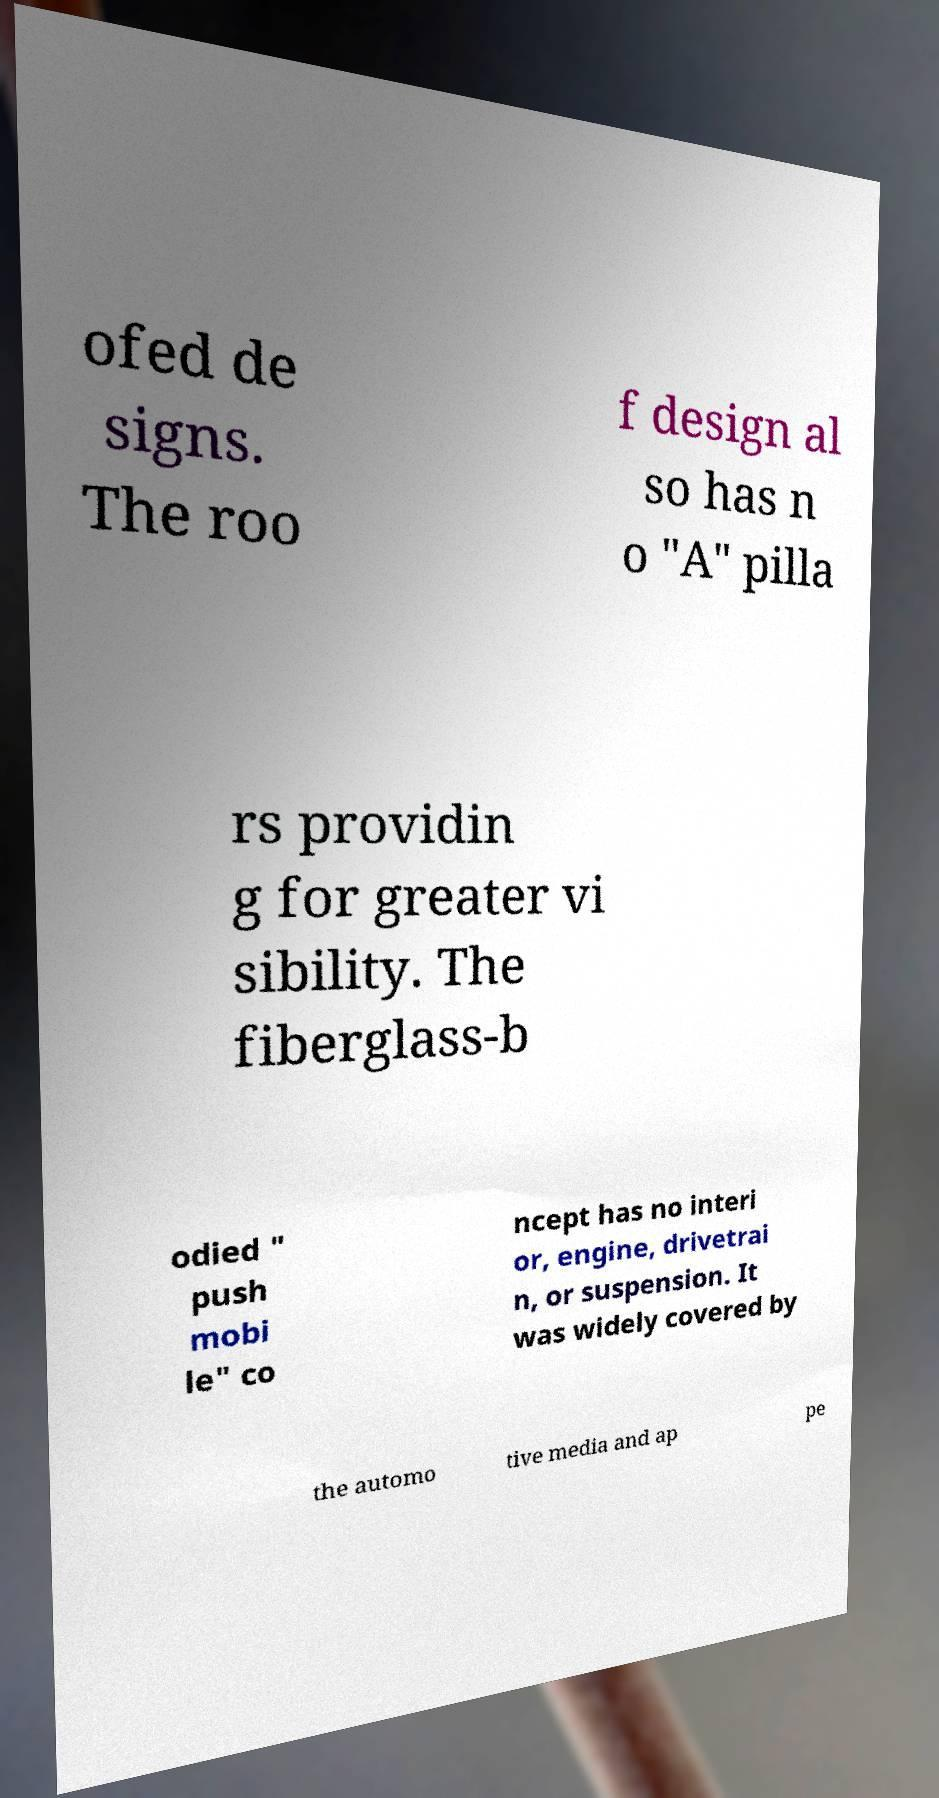Please read and relay the text visible in this image. What does it say? ofed de signs. The roo f design al so has n o "A" pilla rs providin g for greater vi sibility. The fiberglass-b odied " push mobi le" co ncept has no interi or, engine, drivetrai n, or suspension. It was widely covered by the automo tive media and ap pe 